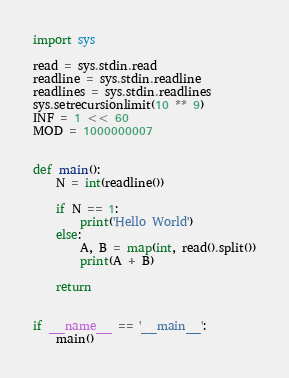<code> <loc_0><loc_0><loc_500><loc_500><_Python_>import sys

read = sys.stdin.read
readline = sys.stdin.readline
readlines = sys.stdin.readlines
sys.setrecursionlimit(10 ** 9)
INF = 1 << 60
MOD = 1000000007


def main():
    N = int(readline())

    if N == 1:
        print('Hello World')
    else:
        A, B = map(int, read().split())
        print(A + B)

    return


if __name__ == '__main__':
    main()
</code> 